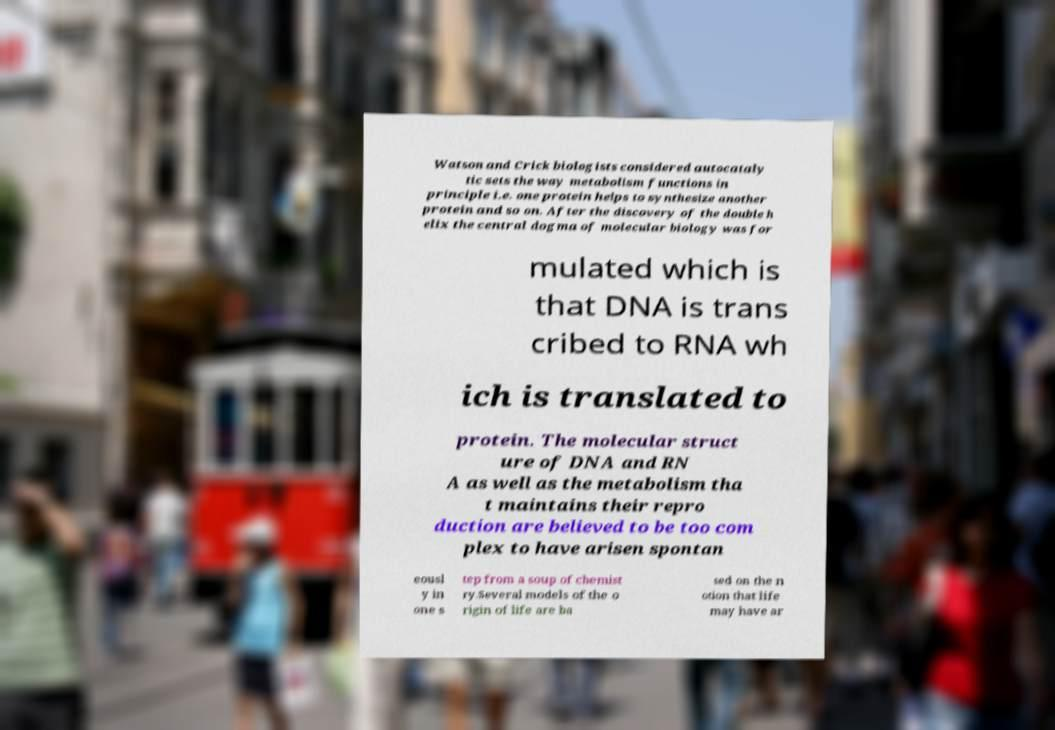There's text embedded in this image that I need extracted. Can you transcribe it verbatim? Watson and Crick biologists considered autocataly tic sets the way metabolism functions in principle i.e. one protein helps to synthesize another protein and so on. After the discovery of the double h elix the central dogma of molecular biology was for mulated which is that DNA is trans cribed to RNA wh ich is translated to protein. The molecular struct ure of DNA and RN A as well as the metabolism tha t maintains their repro duction are believed to be too com plex to have arisen spontan eousl y in one s tep from a soup of chemist ry.Several models of the o rigin of life are ba sed on the n otion that life may have ar 